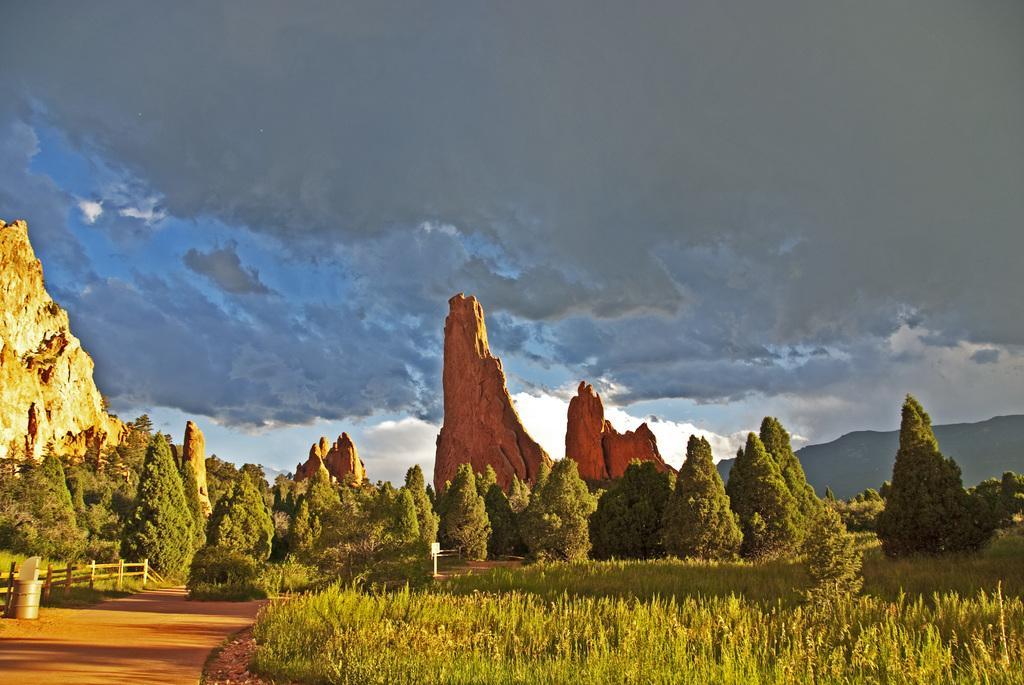Please provide a concise description of this image. In this image there is grass on the ground. There are trees, mountains and the sky is cloudy. 